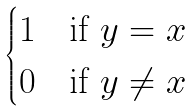<formula> <loc_0><loc_0><loc_500><loc_500>\begin{cases} 1 & \text {if $y=x$} \\ 0 & \text {if $y \neq x$} \end{cases}</formula> 